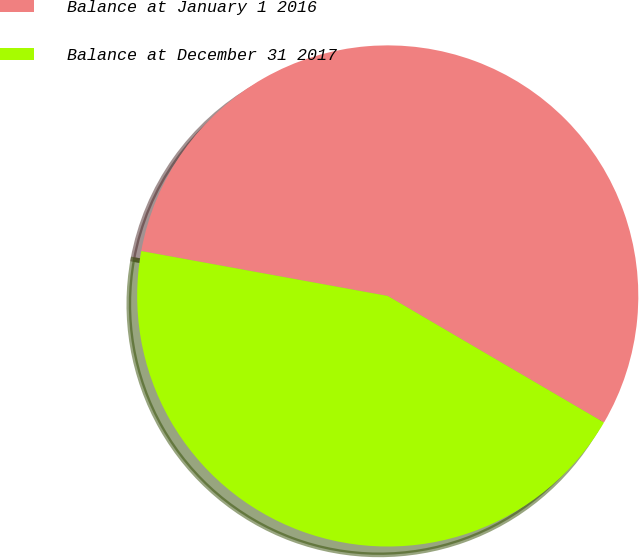<chart> <loc_0><loc_0><loc_500><loc_500><pie_chart><fcel>Balance at January 1 2016<fcel>Balance at December 31 2017<nl><fcel>55.56%<fcel>44.44%<nl></chart> 